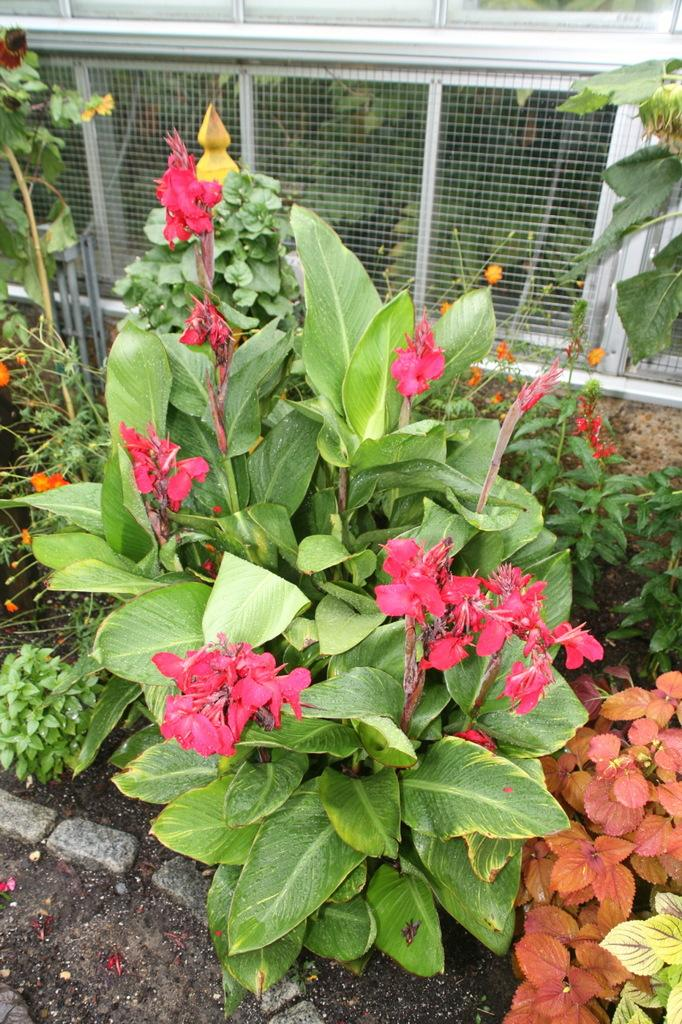What type of plants can be seen in the image? There are plants with flowers in the image. What is placed in front of the plants? There are stones in front of the plants. What can be seen behind the plants? There appears to be a wire fence behind the plants. What color is the stocking hanging from the wire fence in the image? There is no stocking hanging from the wire fence in the image. 